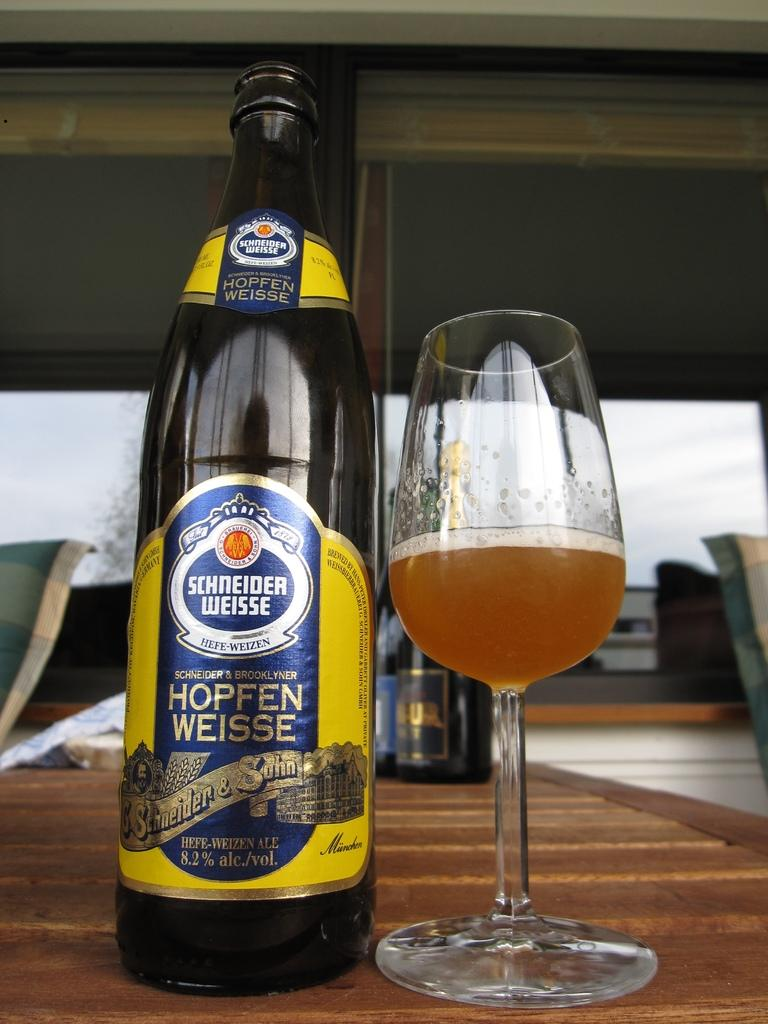<image>
Relay a brief, clear account of the picture shown. Bottle of Schneider Weisse next to a half filled glass of beer. 